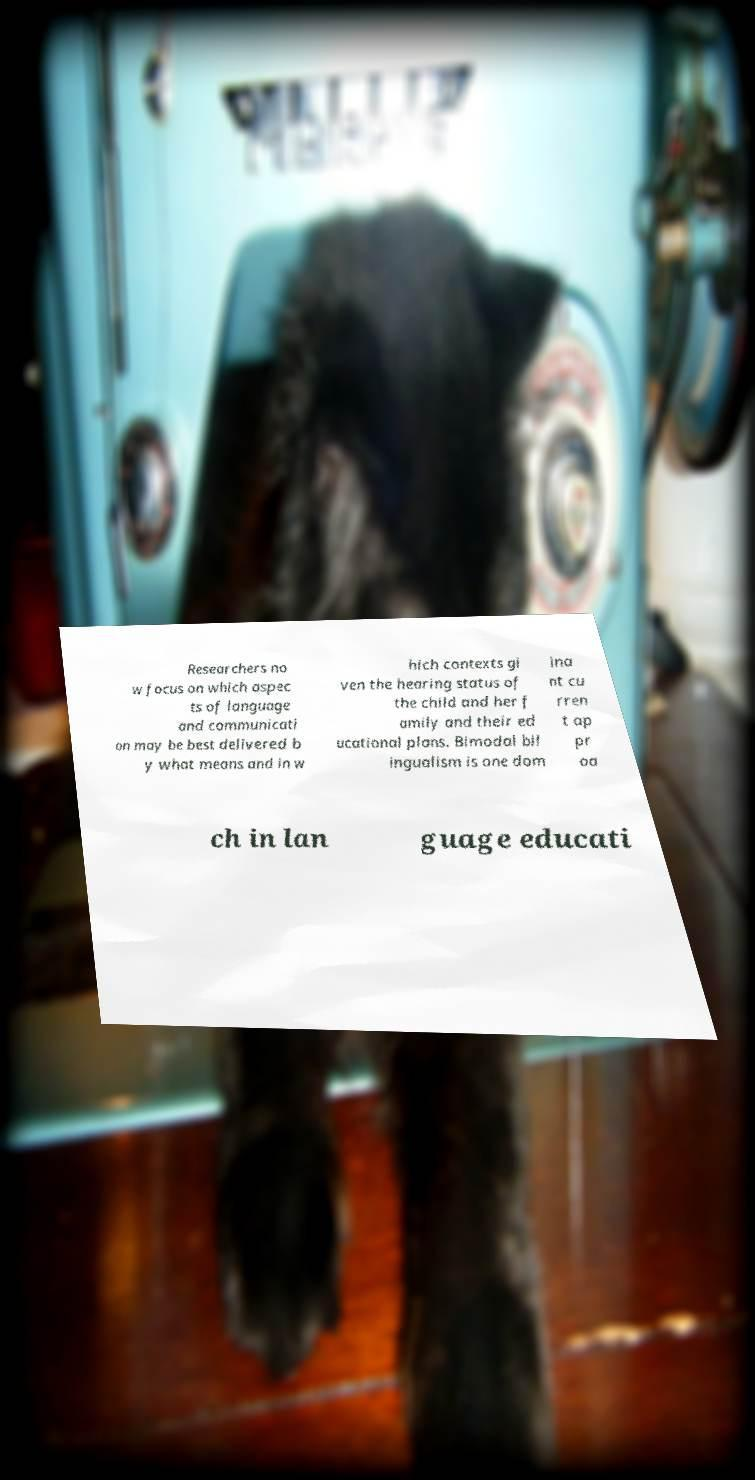Could you assist in decoding the text presented in this image and type it out clearly? Researchers no w focus on which aspec ts of language and communicati on may be best delivered b y what means and in w hich contexts gi ven the hearing status of the child and her f amily and their ed ucational plans. Bimodal bil ingualism is one dom ina nt cu rren t ap pr oa ch in lan guage educati 